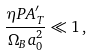Convert formula to latex. <formula><loc_0><loc_0><loc_500><loc_500>\frac { \eta P A ^ { \prime } _ { T } } { \Omega _ { B } a _ { 0 } ^ { 2 } } \ll 1 \, ,</formula> 